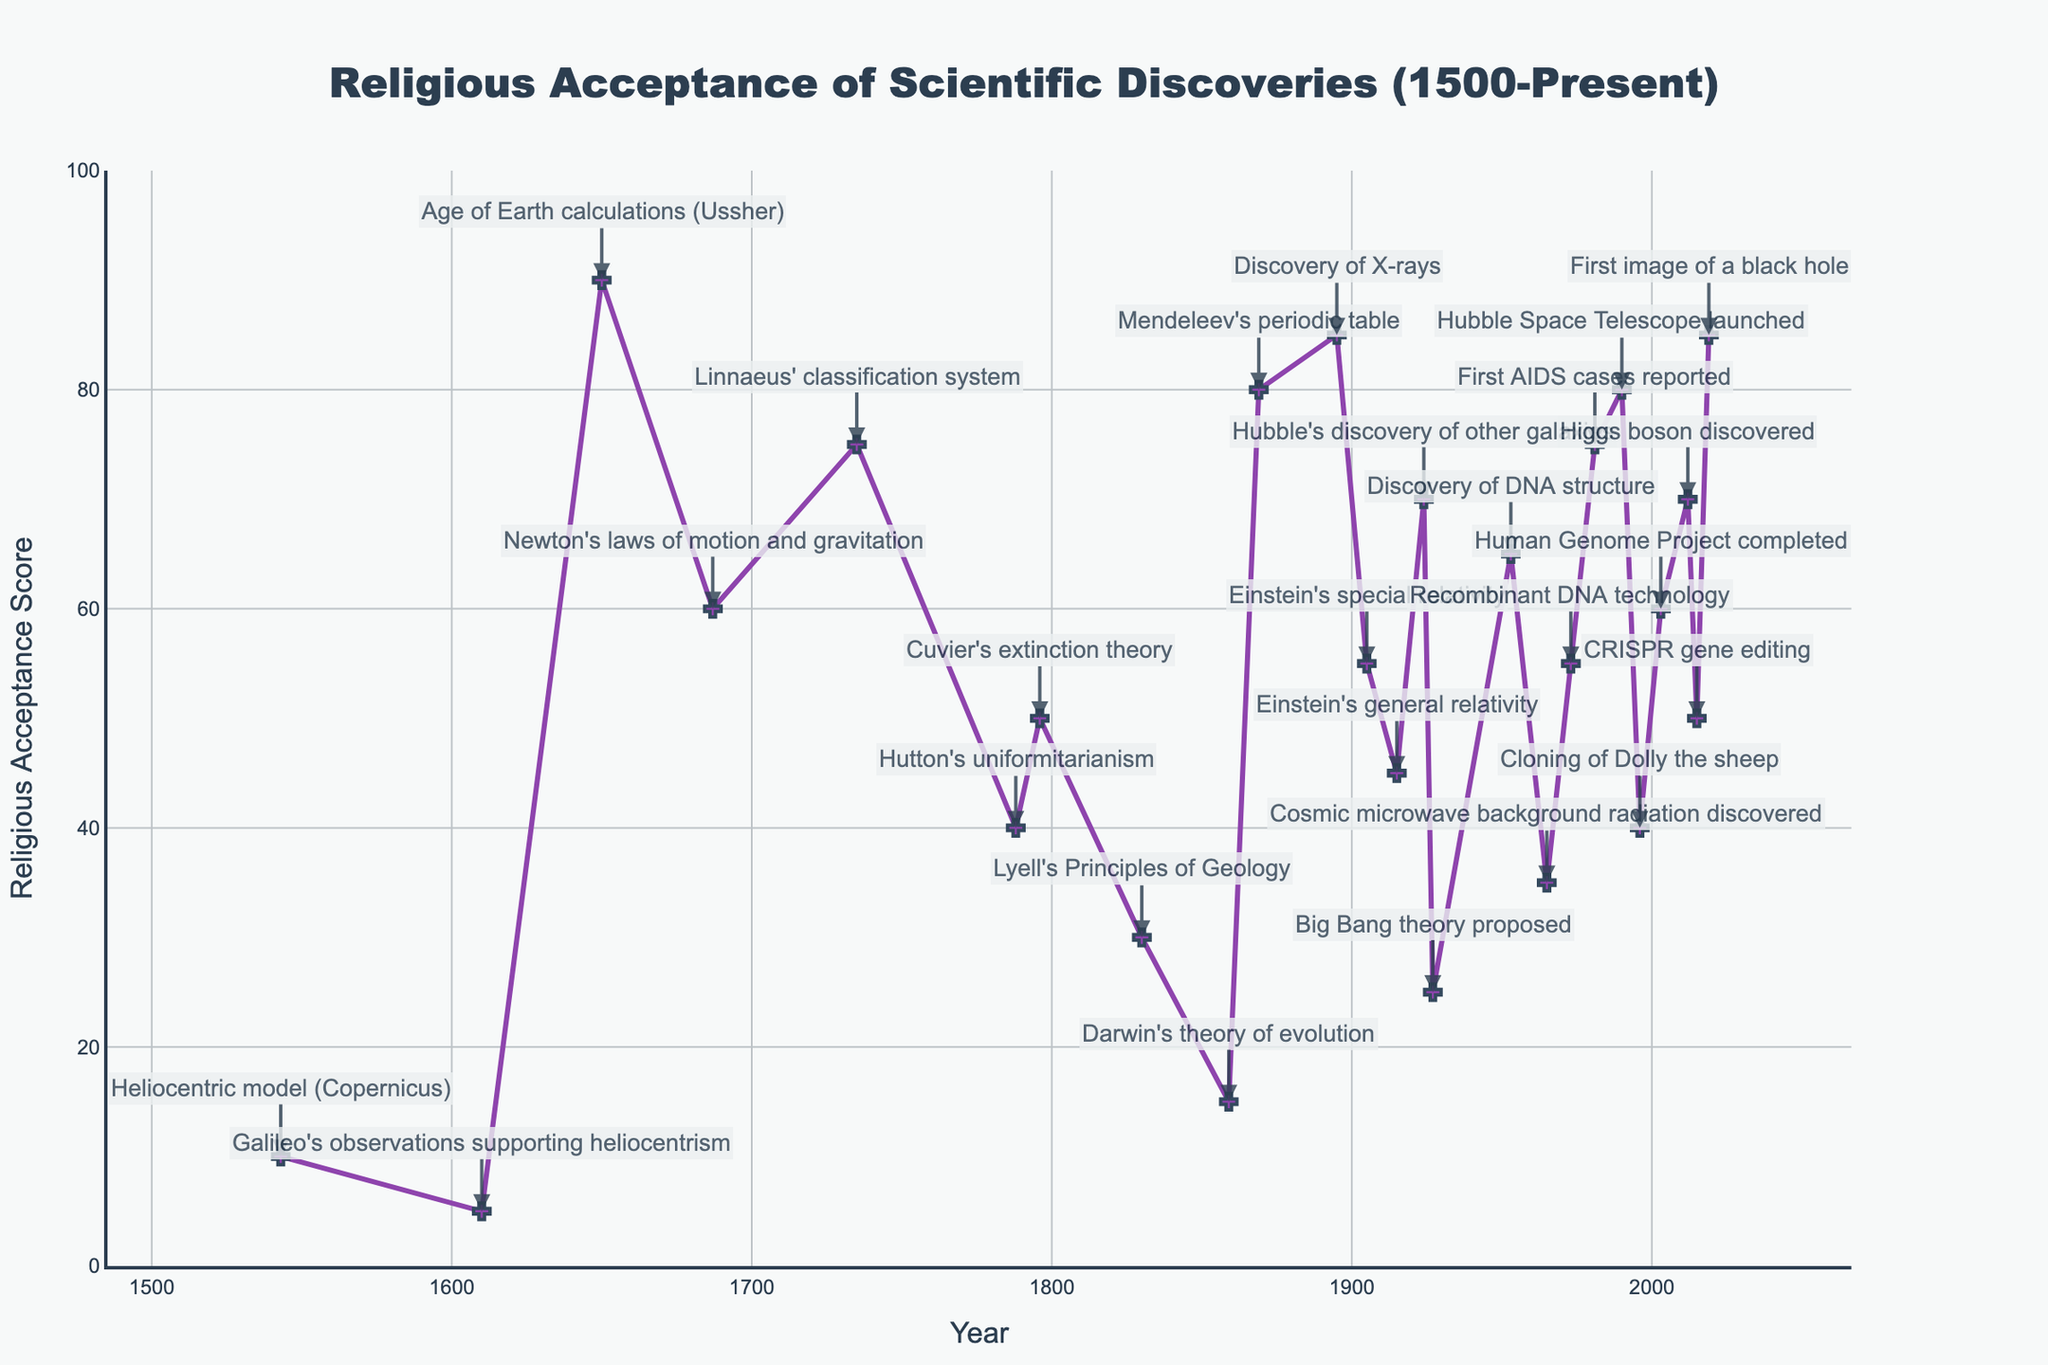What scientific discovery in the 19th century had the highest religious acceptance score? Look for the scientific discovery in the 19th century with the highest y-value in the figure. Mendeleev's periodic table in 1869 has a score of 80.
Answer: Mendeleev's periodic table How did the religious acceptance of Darwin's theory of evolution in 1859 compare to Linnaeus' classification system in 1735? Identify the scores for both discoveries: Darwin's theory of evolution in 1859 has a score of 15, while Linnaeus' classification system in 1735 has a score of 75. Compare the two values.
Answer: Darwin's theory of evolution was less accepted By how much did the religious acceptance score change from Einstein's special relativity in 1905 to his general relativity in 1915? Find the scores for both years: special relativity (1905) is 55, and general relativity (1915) is 45. Subtract the score for 1915 from the score for 1905: 55 - 45 = 10.
Answer: Decreased by 10 Which scientific discovery in the 20th century had a religious acceptance score closest to the median score of all the discoveries listed in the figure? Approximate the median by listing all scores and finding the middle value: median is 55. Look for the 20th-century discovery with a score close to 55. Einstein's special relativity (1905), Recombinant DNA technology (1973), and Cloning of Dolly the sheep (1996) all score 55. Any could be correct if strictly following chronological sequence is not prioritized.
Answer: Recombinant DNA technology/Einstein's special relativity/Cloning of Dolly the sheep What are the extreme points (highest and lowest) of religious acceptance scores, and which scientific discoveries do they correspond to? Identify the highest and lowest y-values: highest is 90 (Ussher's Age of Earth calculations, 1650), and lowest is 5 (Galileo's observations, 1610).
Answer: 90 for Age of Earth calculations, 5 for Galileo's observations What's the average religious acceptance score for all scientific discoveries in the 20th century presented in the figure? List all 20th-century discoveries and their scores: 45, 65, 35, 55, 75, 80, 40, 60. Sum them: 455. Divide by the number of discoveries: 455 / 8 = 56.875.
Answer: 56.875 